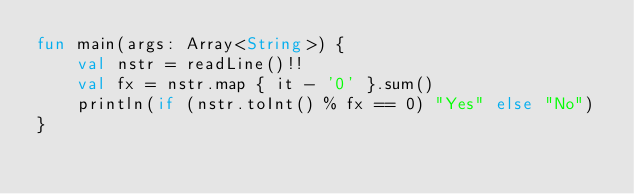<code> <loc_0><loc_0><loc_500><loc_500><_Kotlin_>fun main(args: Array<String>) {
    val nstr = readLine()!!
    val fx = nstr.map { it - '0' }.sum()
    println(if (nstr.toInt() % fx == 0) "Yes" else "No")
}
</code> 